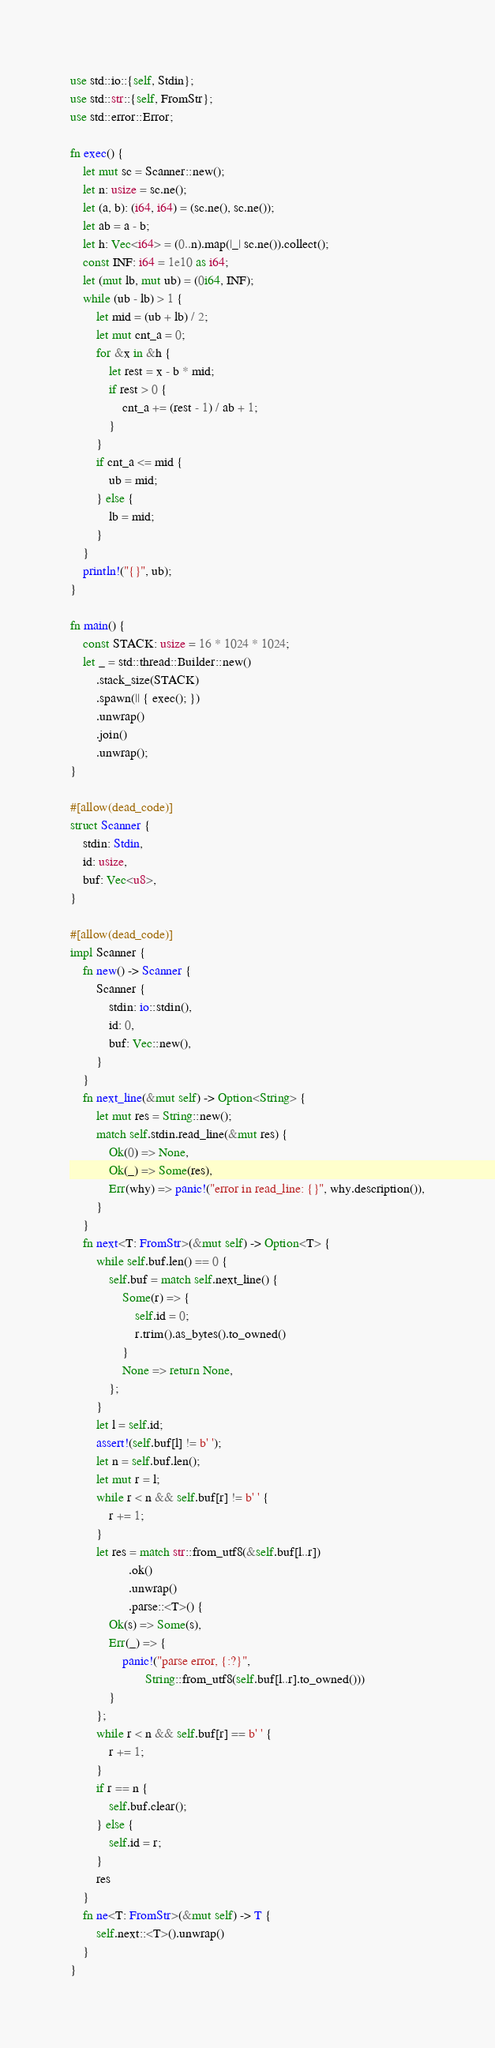<code> <loc_0><loc_0><loc_500><loc_500><_Rust_>use std::io::{self, Stdin};
use std::str::{self, FromStr};
use std::error::Error;

fn exec() {
    let mut sc = Scanner::new();
    let n: usize = sc.ne();
    let (a, b): (i64, i64) = (sc.ne(), sc.ne());
    let ab = a - b;
    let h: Vec<i64> = (0..n).map(|_| sc.ne()).collect();
    const INF: i64 = 1e10 as i64;
    let (mut lb, mut ub) = (0i64, INF);
    while (ub - lb) > 1 {
        let mid = (ub + lb) / 2;
        let mut cnt_a = 0;
        for &x in &h {
            let rest = x - b * mid;
            if rest > 0 {
                cnt_a += (rest - 1) / ab + 1;
            }
        }
        if cnt_a <= mid {
            ub = mid;
        } else {
            lb = mid;
        }
    }
    println!("{}", ub);
}

fn main() {
    const STACK: usize = 16 * 1024 * 1024;
    let _ = std::thread::Builder::new()
        .stack_size(STACK)
        .spawn(|| { exec(); })
        .unwrap()
        .join()
        .unwrap();
}

#[allow(dead_code)]
struct Scanner {
    stdin: Stdin,
    id: usize,
    buf: Vec<u8>,
}

#[allow(dead_code)]
impl Scanner {
    fn new() -> Scanner {
        Scanner {
            stdin: io::stdin(),
            id: 0,
            buf: Vec::new(),
        }
    }
    fn next_line(&mut self) -> Option<String> {
        let mut res = String::new();
        match self.stdin.read_line(&mut res) {
            Ok(0) => None,
            Ok(_) => Some(res),
            Err(why) => panic!("error in read_line: {}", why.description()),
        }
    }
    fn next<T: FromStr>(&mut self) -> Option<T> {
        while self.buf.len() == 0 {
            self.buf = match self.next_line() {
                Some(r) => {
                    self.id = 0;
                    r.trim().as_bytes().to_owned()
                }
                None => return None,
            };
        }
        let l = self.id;
        assert!(self.buf[l] != b' ');
        let n = self.buf.len();
        let mut r = l;
        while r < n && self.buf[r] != b' ' {
            r += 1;
        }
        let res = match str::from_utf8(&self.buf[l..r])
                  .ok()
                  .unwrap()
                  .parse::<T>() {
            Ok(s) => Some(s),
            Err(_) => {
                panic!("parse error, {:?}",
                       String::from_utf8(self.buf[l..r].to_owned()))
            }
        };
        while r < n && self.buf[r] == b' ' {
            r += 1;
        }
        if r == n {
            self.buf.clear();
        } else {
            self.id = r;
        }
        res
    }
    fn ne<T: FromStr>(&mut self) -> T {
        self.next::<T>().unwrap()
    }
}
</code> 